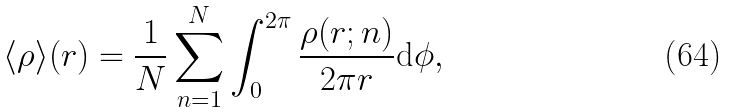Convert formula to latex. <formula><loc_0><loc_0><loc_500><loc_500>\langle \rho \rangle ( r ) = \frac { 1 } { N } \sum _ { n = 1 } ^ { N } \int _ { 0 } ^ { 2 \pi } \frac { \rho ( { r } ; n ) } { 2 \pi r } \text {d} \phi ,</formula> 